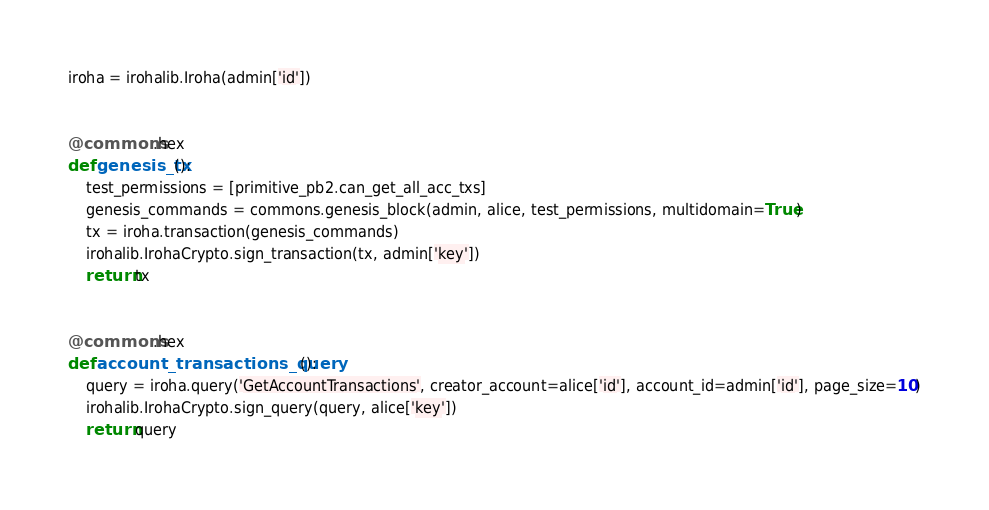<code> <loc_0><loc_0><loc_500><loc_500><_Python_>iroha = irohalib.Iroha(admin['id'])


@commons.hex
def genesis_tx():
    test_permissions = [primitive_pb2.can_get_all_acc_txs]
    genesis_commands = commons.genesis_block(admin, alice, test_permissions, multidomain=True)
    tx = iroha.transaction(genesis_commands)
    irohalib.IrohaCrypto.sign_transaction(tx, admin['key'])
    return tx


@commons.hex
def account_transactions_query():
    query = iroha.query('GetAccountTransactions', creator_account=alice['id'], account_id=admin['id'], page_size=10)
    irohalib.IrohaCrypto.sign_query(query, alice['key'])
    return query
</code> 